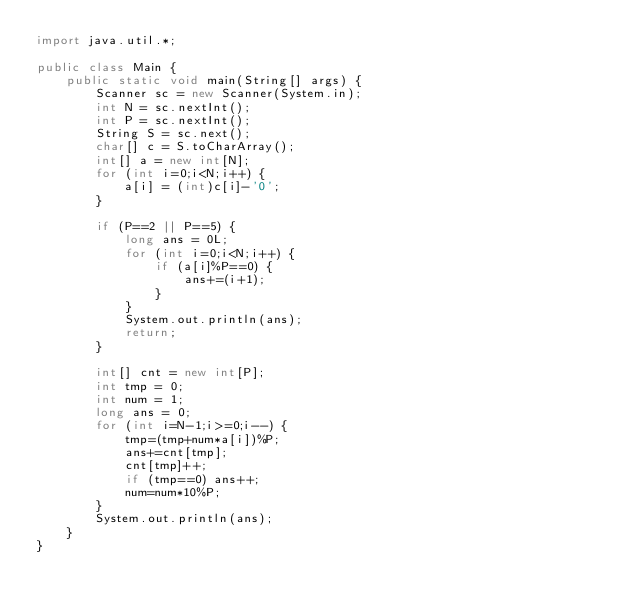Convert code to text. <code><loc_0><loc_0><loc_500><loc_500><_Java_>import java.util.*;

public class Main {
    public static void main(String[] args) {
        Scanner sc = new Scanner(System.in);
        int N = sc.nextInt();
        int P = sc.nextInt();
        String S = sc.next();
        char[] c = S.toCharArray();
        int[] a = new int[N];
        for (int i=0;i<N;i++) {
            a[i] = (int)c[i]-'0';
        }

        if (P==2 || P==5) {
            long ans = 0L;
            for (int i=0;i<N;i++) {
                if (a[i]%P==0) {
                    ans+=(i+1);
                }
            }
            System.out.println(ans);
            return;
        }

        int[] cnt = new int[P];
        int tmp = 0;
        int num = 1;
        long ans = 0;
        for (int i=N-1;i>=0;i--) {
            tmp=(tmp+num*a[i])%P;
            ans+=cnt[tmp];
            cnt[tmp]++;
            if (tmp==0) ans++;
            num=num*10%P;
        }
        System.out.println(ans);
    }
}</code> 